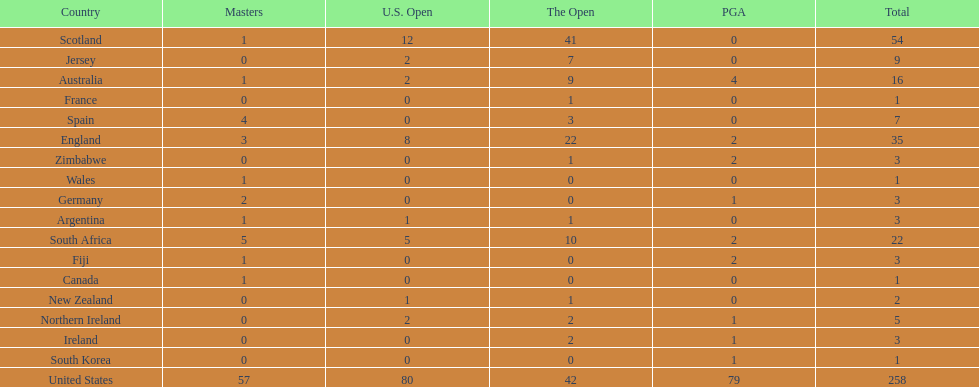How many total championships does spain have? 7. 